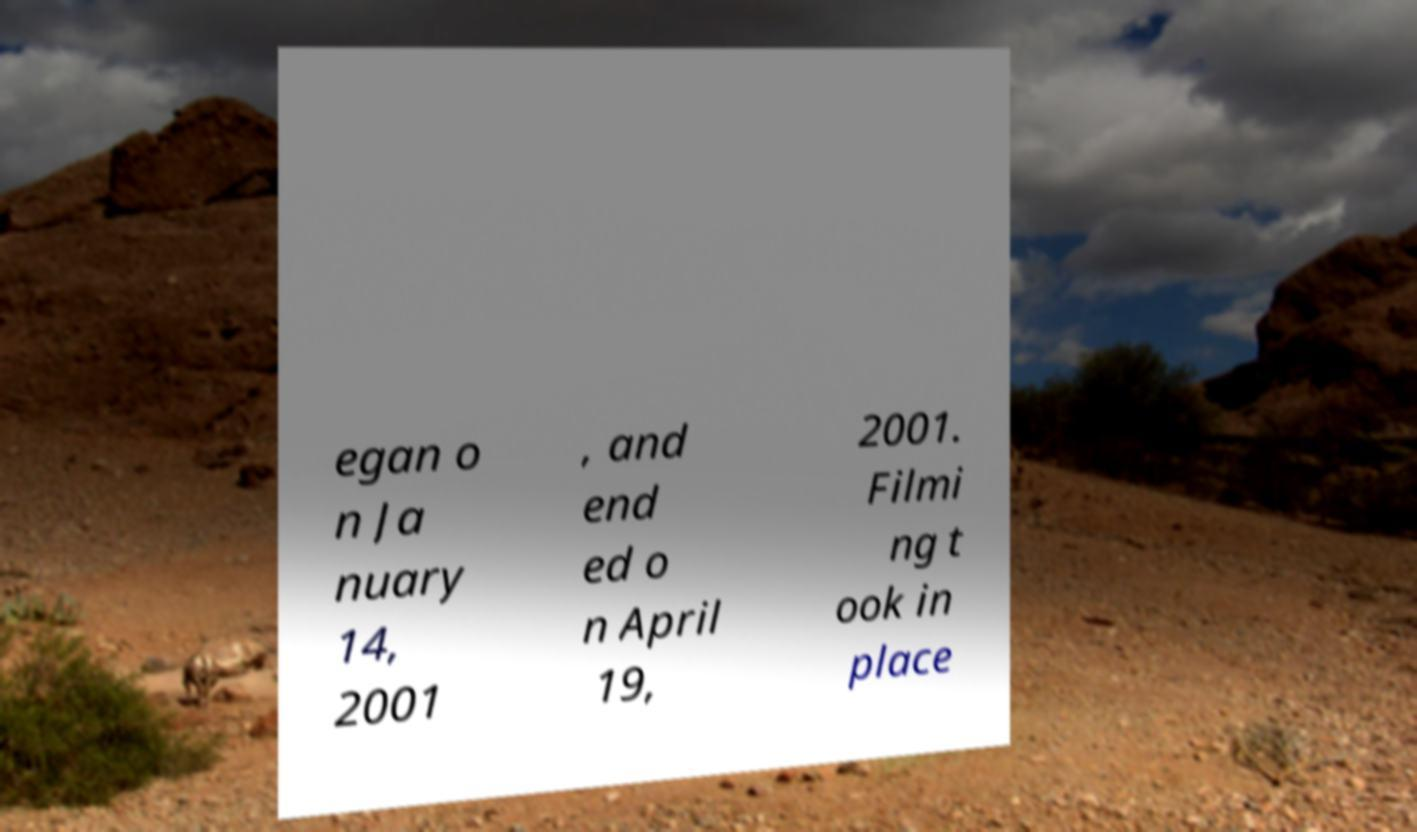Could you assist in decoding the text presented in this image and type it out clearly? egan o n Ja nuary 14, 2001 , and end ed o n April 19, 2001. Filmi ng t ook in place 